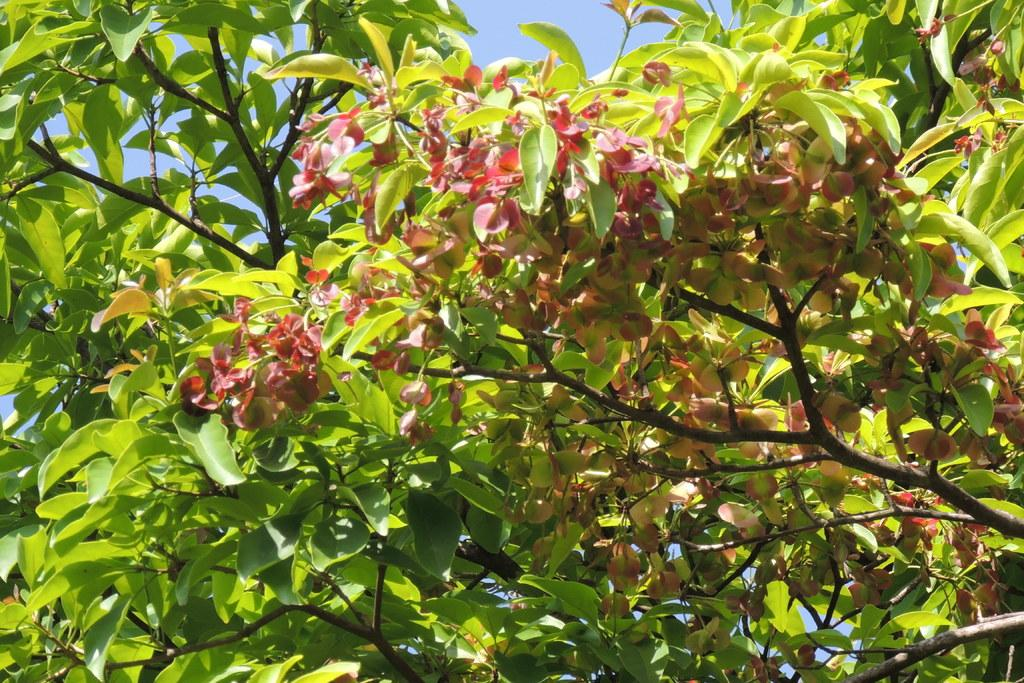What type of vegetation can be seen in the image? There are trees in the image. What color are the trees? The trees are green in color. What can be seen in the background of the image? The sky is visible in the background of the image. What color is the sky? The sky is blue in color. What time of day is the son playing in the image? There is no son or indication of time of day present in the image; it only features trees and a blue sky. 